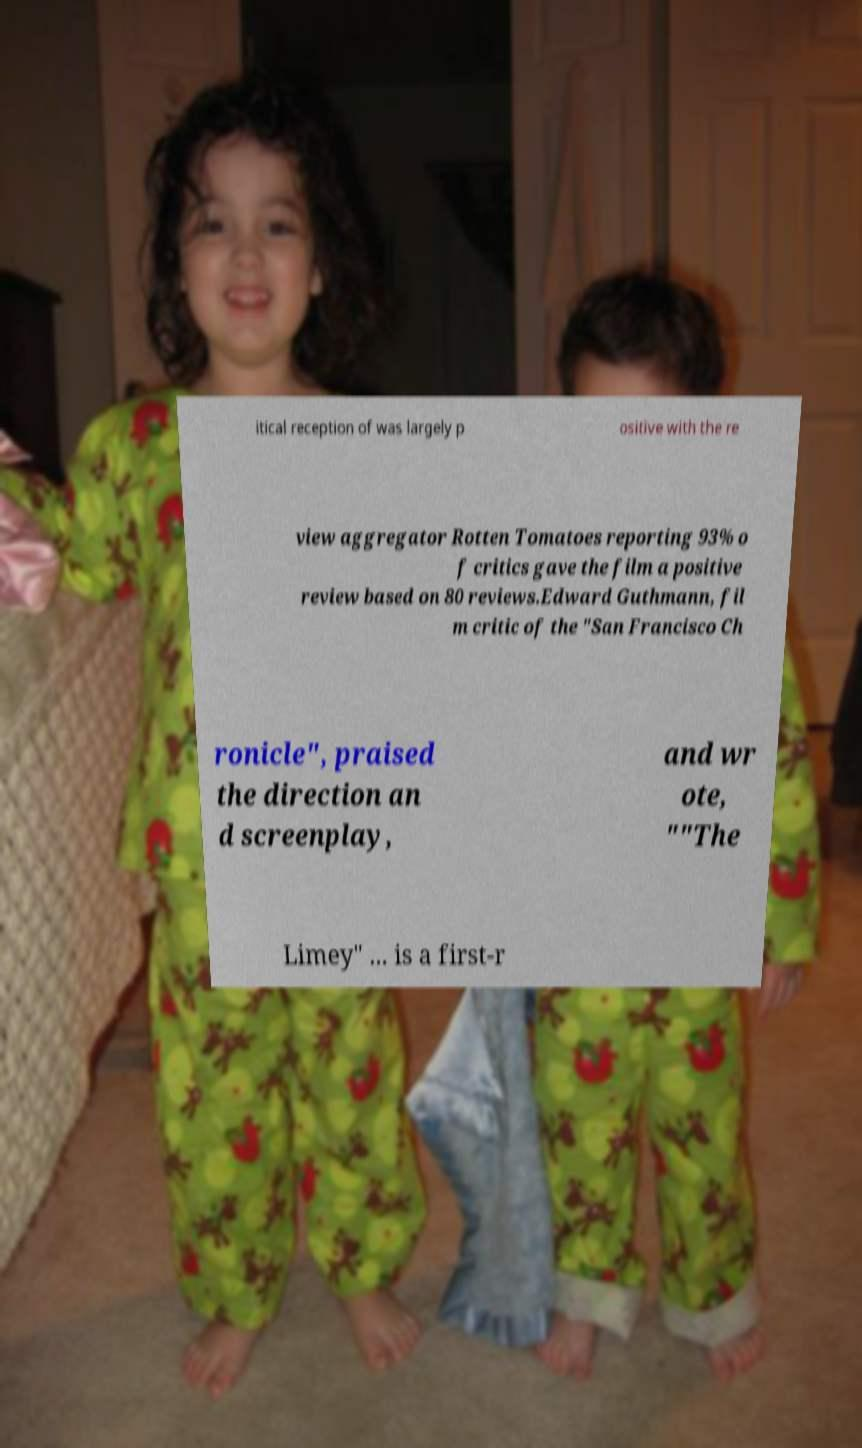Please identify and transcribe the text found in this image. itical reception of was largely p ositive with the re view aggregator Rotten Tomatoes reporting 93% o f critics gave the film a positive review based on 80 reviews.Edward Guthmann, fil m critic of the "San Francisco Ch ronicle", praised the direction an d screenplay, and wr ote, ""The Limey" ... is a first-r 